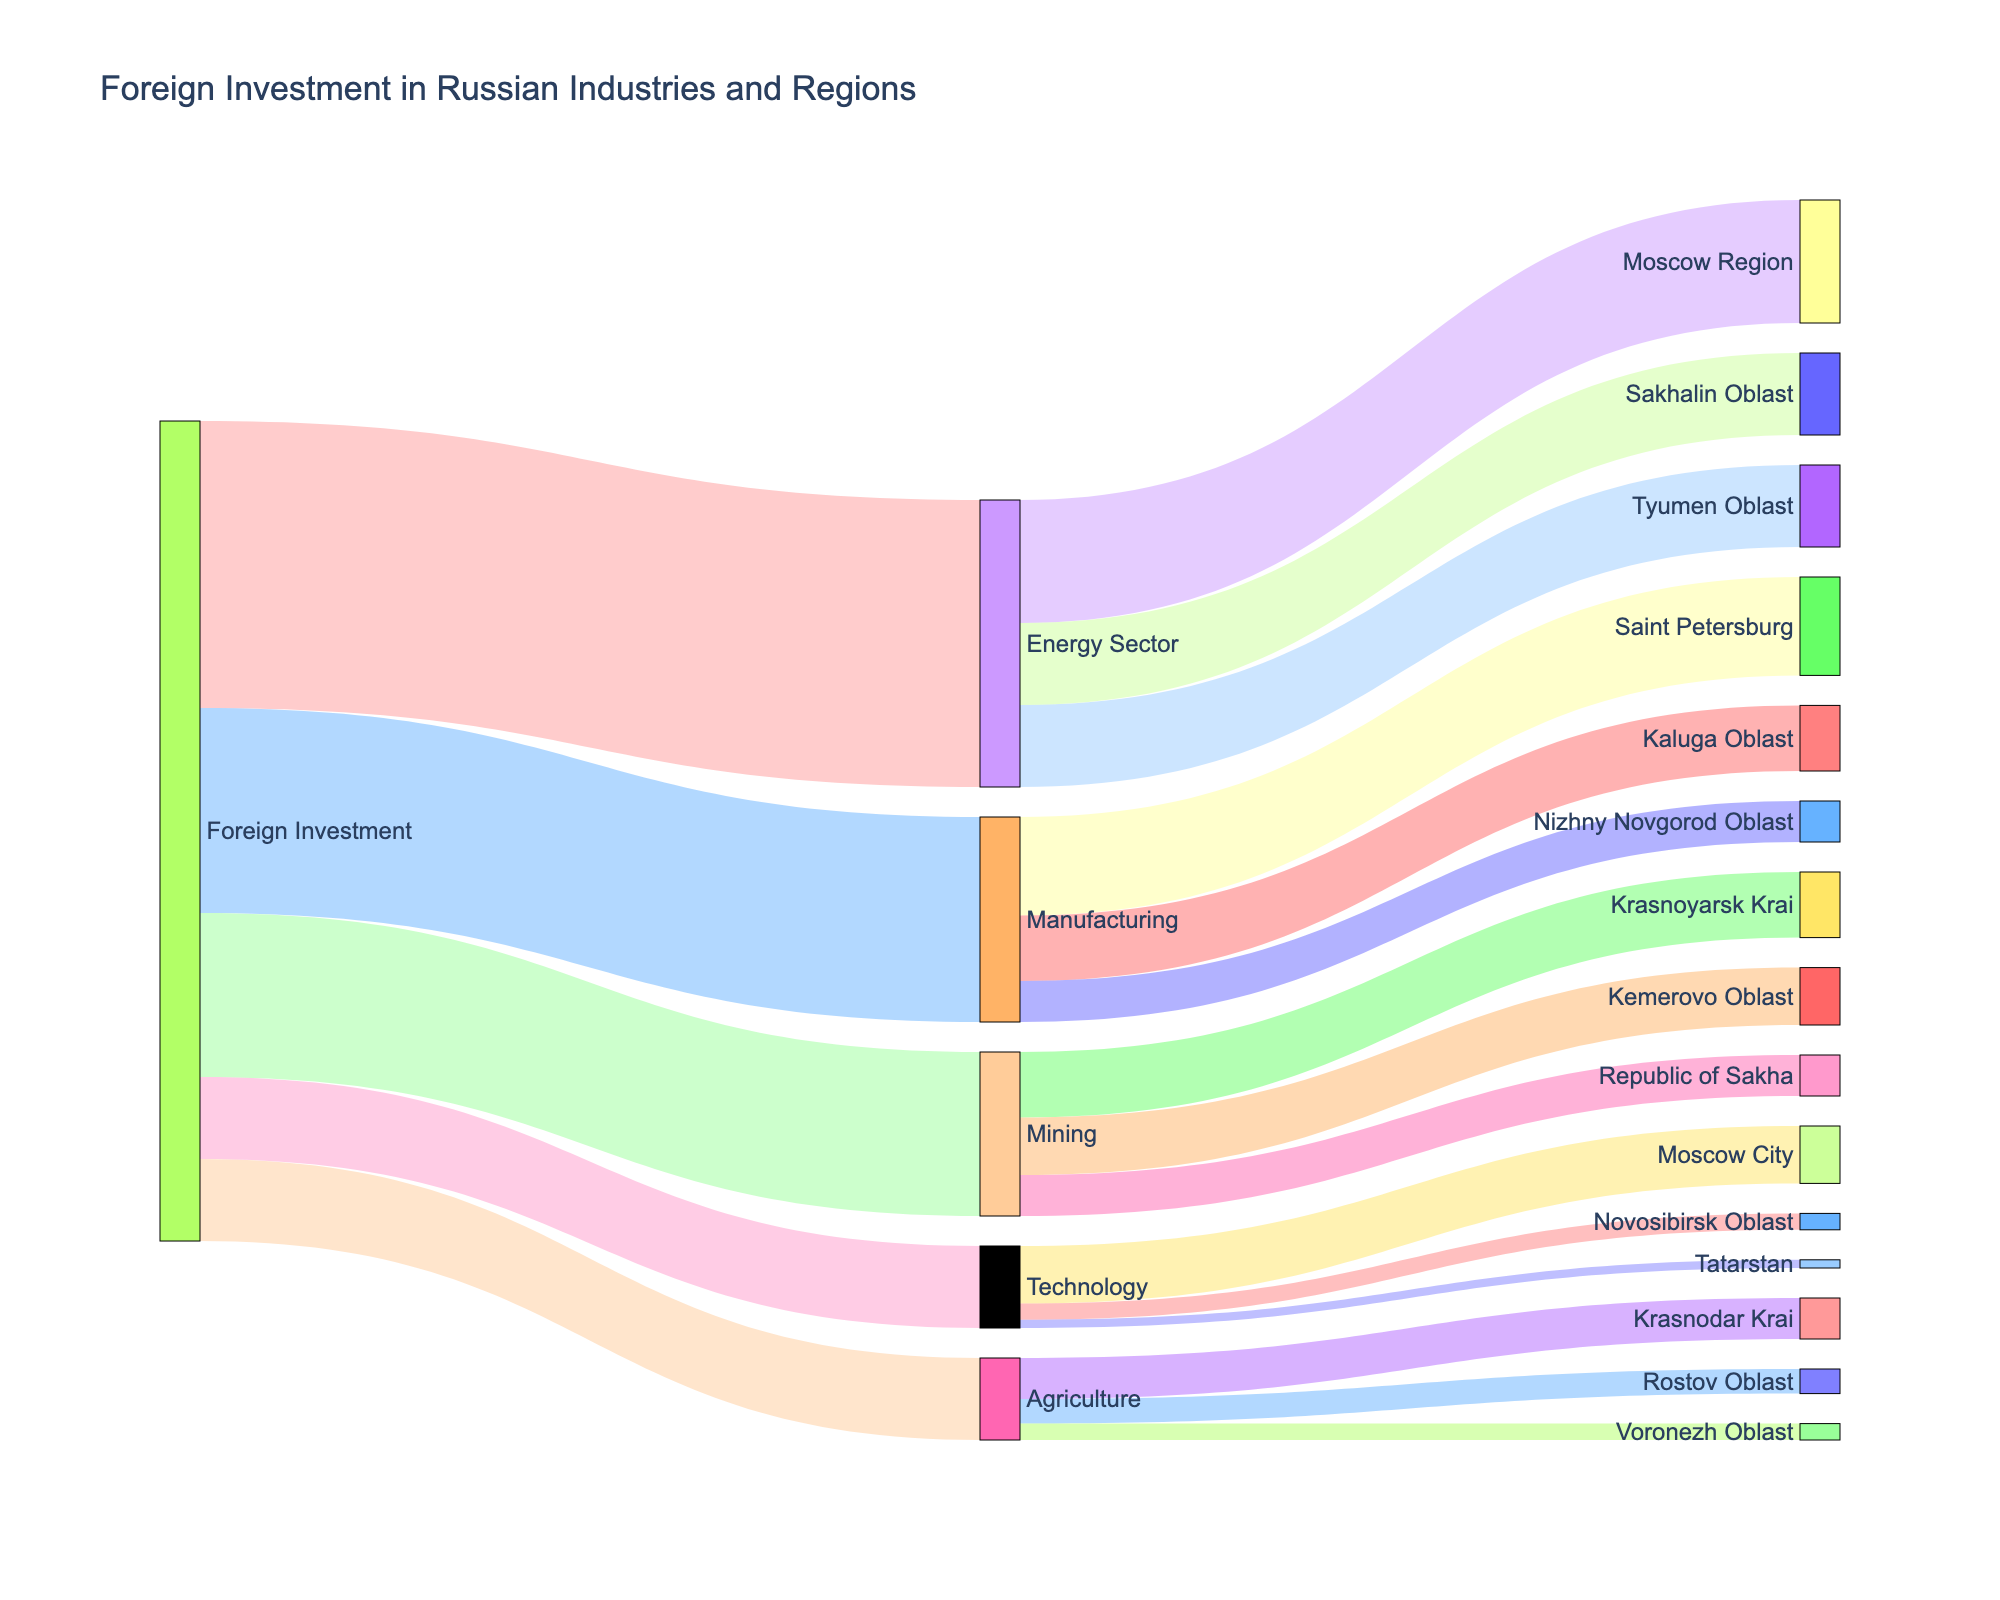what is the title of the figure? The title of the figure is displayed at the top of the Sankey Diagram.
Answer: Foreign Investment in Russian Industries and Regions What industry receives the highest amount of foreign investment? From the first set of connections originating from "Foreign Investment," the "Energy Sector" is the widest, representing the highest value of investment.
Answer: Energy Sector How many regions receive investments from the Agriculture sector? By counting the number of connections from "Agriculture," we observe there are three connections going to different regions.
Answer: 3 Which region receives the smallest investment from Technology? To determine this, we look at the connections from "Technology" to the regions and compare the widths. The narrowest link goes to "Tatarstan."
Answer: Tatarstan What is the total foreign investment in the Moscow Region? The Moscow Region receives investments from both the Energy Sector (15) and Technology (7). Adding these values gives 15 + 7.
Answer: 22 Compare the foreign investment in the Mining sector to the Manufacturing sector. Which one is higher and by how much? The Mining sector receives 20 units of foreign investment and the Manufacturing sector receives 25 units. Subtracting these gives 25 - 20.
Answer: Manufacturing by 5 What percentage of foreign investment goes to the Mining sector? The total foreign investment is the sum of investments in all sectors: 35 (Energy) + 25 (Manufacturing) + 20 (Mining) + 10 (Agriculture) + 10 (Technology) = 100. The Mining sector receives 20, hence (20 / 100) * 100%.
Answer: 20% How much more foreign investment does Saint Petersburg receive compared to Kaluga Oblast? Saint Petersburg receives 12 units of investment in Manufacturing, while Kaluga Oblast receives 8 units. The difference is 12 - 8.
Answer: 4 Which region receives the highest investment from the Mining sector? The connections from the Mining sector show that the widest link goes to the Krasnoyarsk Krai.
Answer: Krasnoyarsk Krai Is the combined foreign investment in Technology and Agriculture greater than the investment in the Energy Sector? The combined investment in Technology (10) and Agriculture (10) is 10 + 10 = 20. The investment in the Energy Sector is 35. Therefore, 20 is less than 35.
Answer: No 